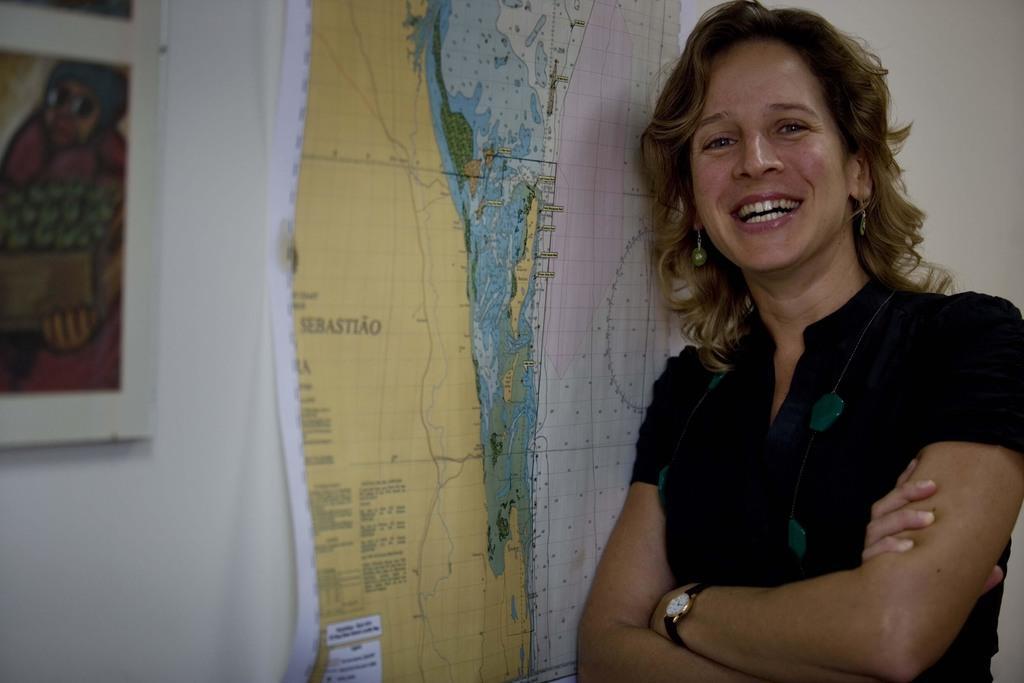Can you describe this image briefly? In this image we can see a woman wearing dress and watch is standing. In the background, we can see a, map and photo frame on the wall. 